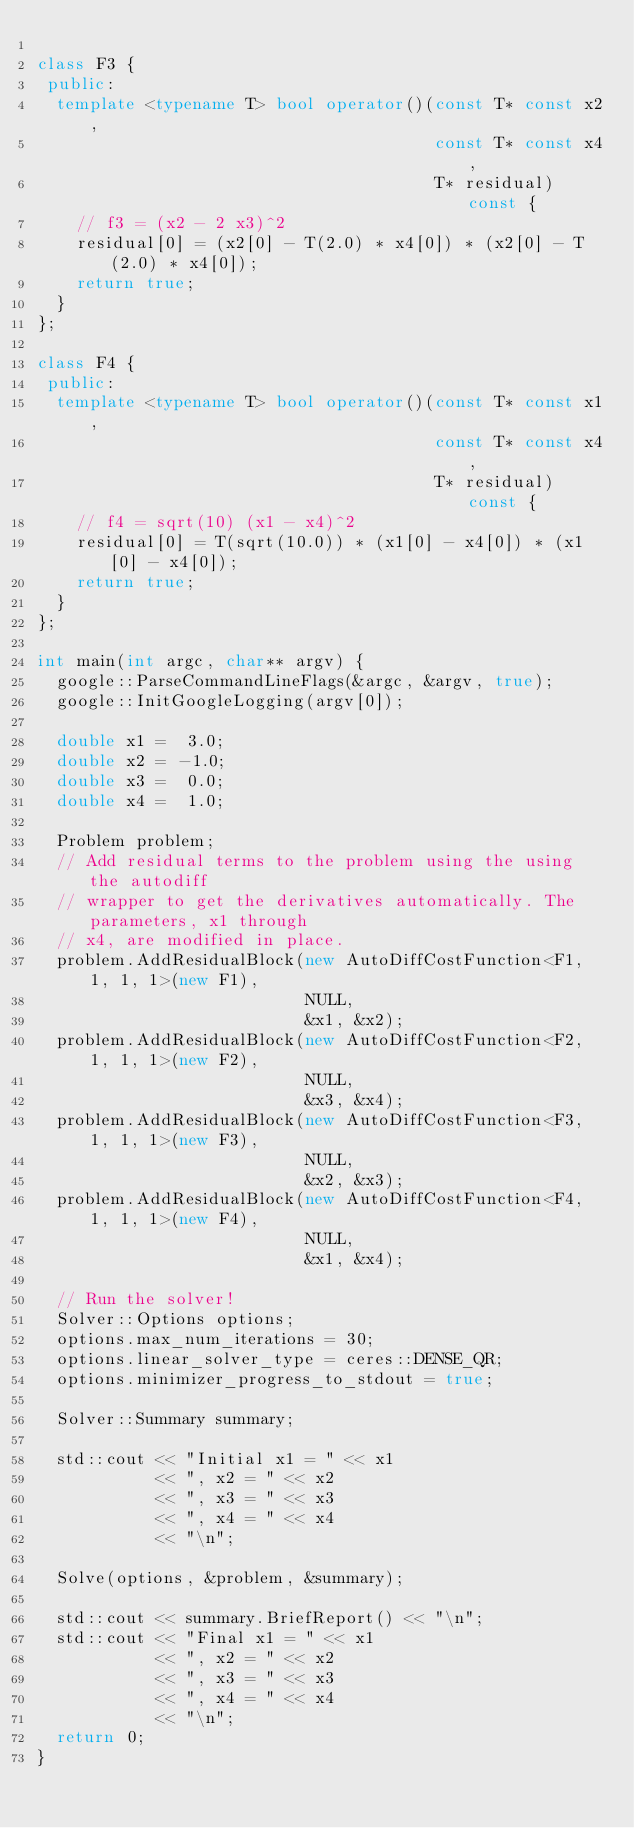<code> <loc_0><loc_0><loc_500><loc_500><_C++_>
class F3 {
 public:
  template <typename T> bool operator()(const T* const x2,
                                        const T* const x4,
                                        T* residual) const {
    // f3 = (x2 - 2 x3)^2
    residual[0] = (x2[0] - T(2.0) * x4[0]) * (x2[0] - T(2.0) * x4[0]);
    return true;
  }
};

class F4 {
 public:
  template <typename T> bool operator()(const T* const x1,
                                        const T* const x4,
                                        T* residual) const {
    // f4 = sqrt(10) (x1 - x4)^2
    residual[0] = T(sqrt(10.0)) * (x1[0] - x4[0]) * (x1[0] - x4[0]);
    return true;
  }
};

int main(int argc, char** argv) {
  google::ParseCommandLineFlags(&argc, &argv, true);
  google::InitGoogleLogging(argv[0]);

  double x1 =  3.0;
  double x2 = -1.0;
  double x3 =  0.0;
  double x4 =  1.0;

  Problem problem;
  // Add residual terms to the problem using the using the autodiff
  // wrapper to get the derivatives automatically. The parameters, x1 through
  // x4, are modified in place.
  problem.AddResidualBlock(new AutoDiffCostFunction<F1, 1, 1, 1>(new F1),
                           NULL,
                           &x1, &x2);
  problem.AddResidualBlock(new AutoDiffCostFunction<F2, 1, 1, 1>(new F2),
                           NULL,
                           &x3, &x4);
  problem.AddResidualBlock(new AutoDiffCostFunction<F3, 1, 1, 1>(new F3),
                           NULL,
                           &x2, &x3);
  problem.AddResidualBlock(new AutoDiffCostFunction<F4, 1, 1, 1>(new F4),
                           NULL,
                           &x1, &x4);

  // Run the solver!
  Solver::Options options;
  options.max_num_iterations = 30;
  options.linear_solver_type = ceres::DENSE_QR;
  options.minimizer_progress_to_stdout = true;

  Solver::Summary summary;

  std::cout << "Initial x1 = " << x1
            << ", x2 = " << x2
            << ", x3 = " << x3
            << ", x4 = " << x4
            << "\n";

  Solve(options, &problem, &summary);

  std::cout << summary.BriefReport() << "\n";
  std::cout << "Final x1 = " << x1
            << ", x2 = " << x2
            << ", x3 = " << x3
            << ", x4 = " << x4
            << "\n";
  return 0;
}
</code> 